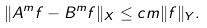<formula> <loc_0><loc_0><loc_500><loc_500>\| A ^ { m } f - B ^ { m } f \| _ { X } \leq c m \| f \| _ { Y } .</formula> 